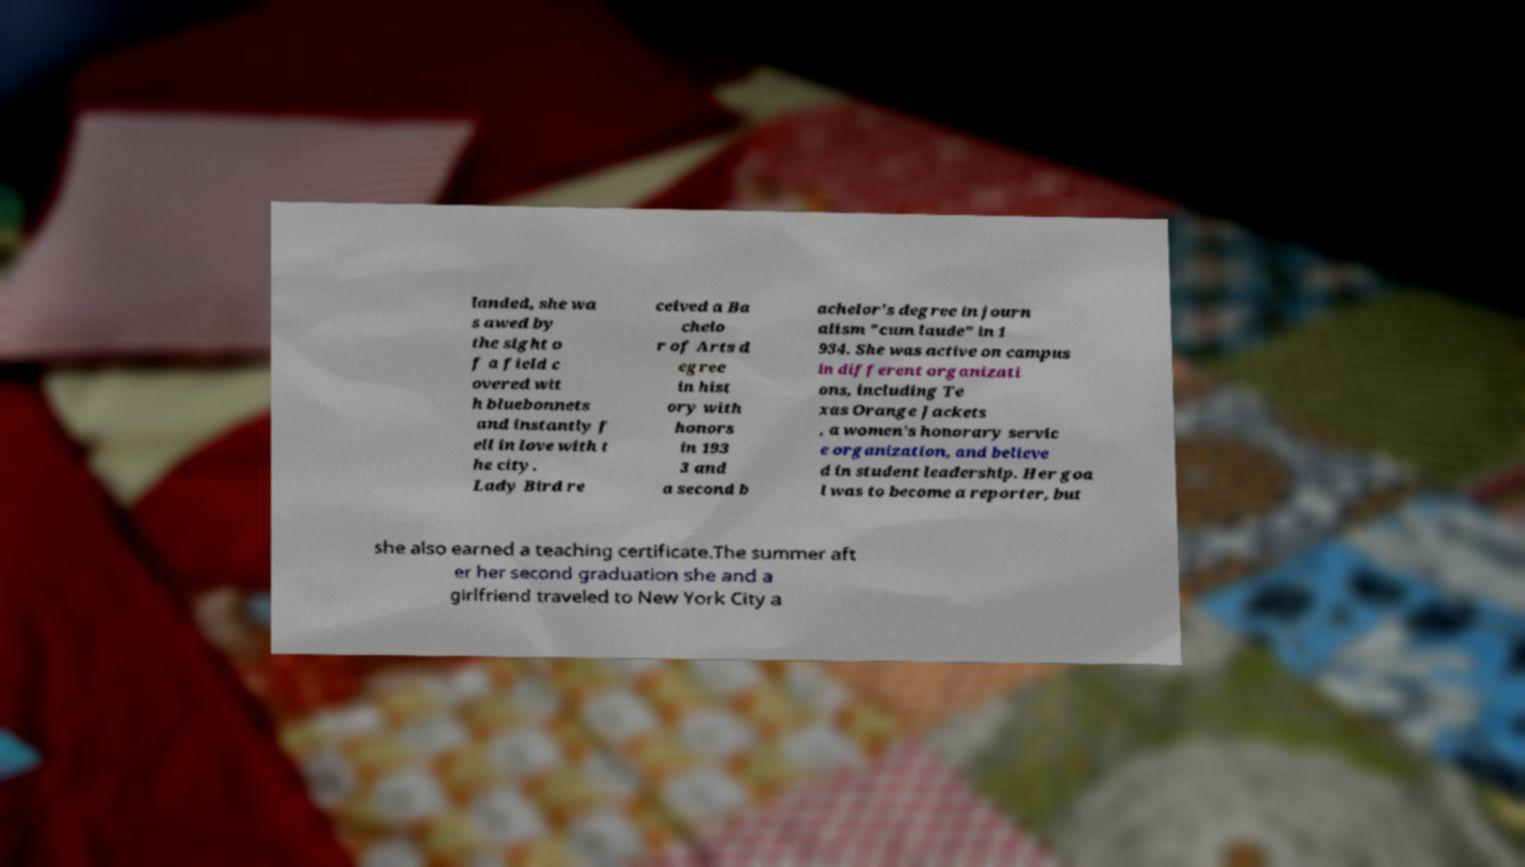Please read and relay the text visible in this image. What does it say? landed, she wa s awed by the sight o f a field c overed wit h bluebonnets and instantly f ell in love with t he city. Lady Bird re ceived a Ba chelo r of Arts d egree in hist ory with honors in 193 3 and a second b achelor's degree in journ alism "cum laude" in 1 934. She was active on campus in different organizati ons, including Te xas Orange Jackets , a women's honorary servic e organization, and believe d in student leadership. Her goa l was to become a reporter, but she also earned a teaching certificate.The summer aft er her second graduation she and a girlfriend traveled to New York City a 